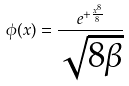Convert formula to latex. <formula><loc_0><loc_0><loc_500><loc_500>\phi ( x ) = \frac { e ^ { + \frac { x ^ { 8 } } { 8 } } } { \sqrt { 8 \beta } }</formula> 